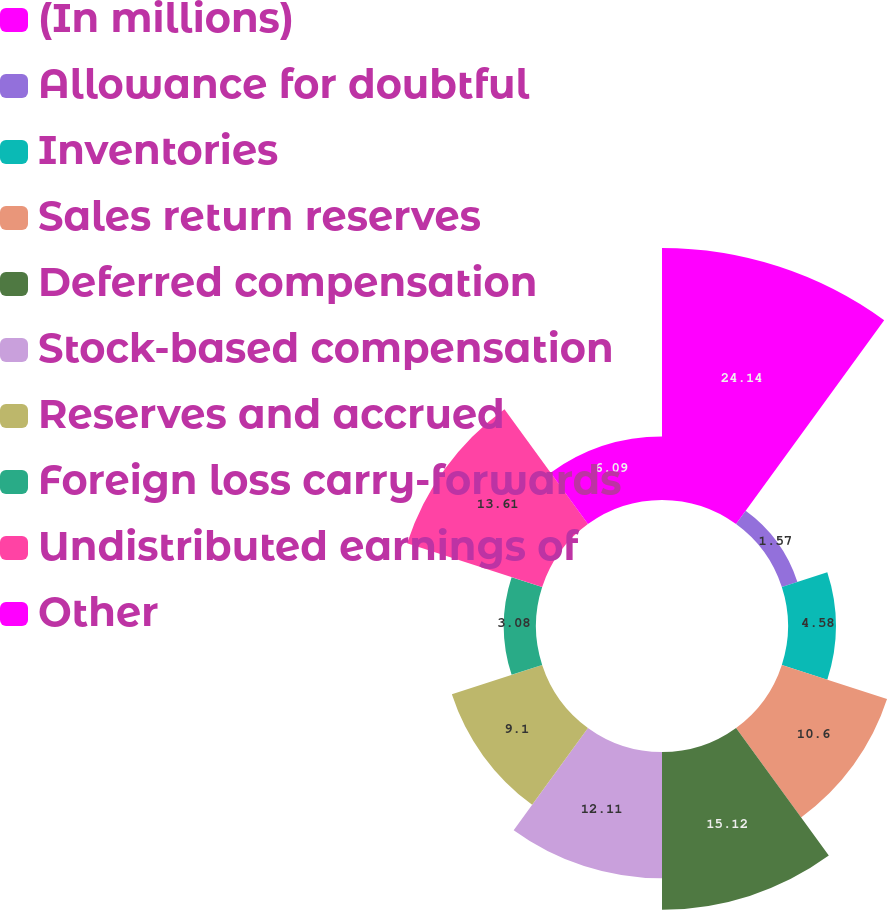<chart> <loc_0><loc_0><loc_500><loc_500><pie_chart><fcel>(In millions)<fcel>Allowance for doubtful<fcel>Inventories<fcel>Sales return reserves<fcel>Deferred compensation<fcel>Stock-based compensation<fcel>Reserves and accrued<fcel>Foreign loss carry-forwards<fcel>Undistributed earnings of<fcel>Other<nl><fcel>24.15%<fcel>1.57%<fcel>4.58%<fcel>10.6%<fcel>15.12%<fcel>12.11%<fcel>9.1%<fcel>3.08%<fcel>13.61%<fcel>6.09%<nl></chart> 